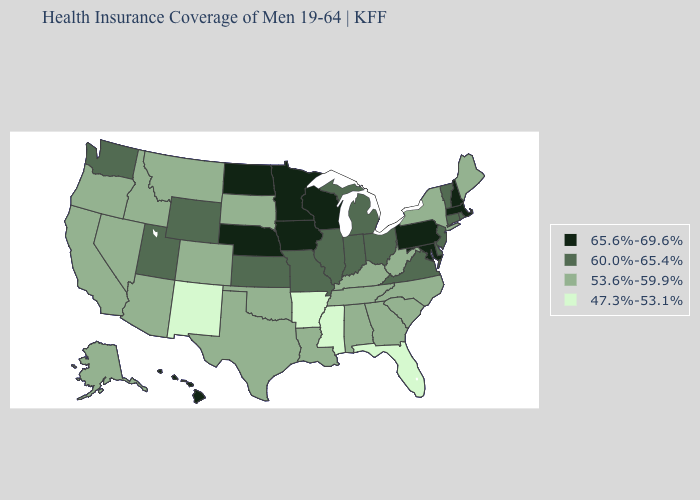Name the states that have a value in the range 60.0%-65.4%?
Be succinct. Connecticut, Delaware, Illinois, Indiana, Kansas, Michigan, Missouri, New Jersey, Ohio, Rhode Island, Utah, Vermont, Virginia, Washington, Wyoming. Does Nebraska have the highest value in the USA?
Keep it brief. Yes. Name the states that have a value in the range 65.6%-69.6%?
Give a very brief answer. Hawaii, Iowa, Maryland, Massachusetts, Minnesota, Nebraska, New Hampshire, North Dakota, Pennsylvania, Wisconsin. Name the states that have a value in the range 47.3%-53.1%?
Be succinct. Arkansas, Florida, Mississippi, New Mexico. Is the legend a continuous bar?
Answer briefly. No. What is the value of Massachusetts?
Be succinct. 65.6%-69.6%. Which states hav the highest value in the MidWest?
Short answer required. Iowa, Minnesota, Nebraska, North Dakota, Wisconsin. Name the states that have a value in the range 53.6%-59.9%?
Quick response, please. Alabama, Alaska, Arizona, California, Colorado, Georgia, Idaho, Kentucky, Louisiana, Maine, Montana, Nevada, New York, North Carolina, Oklahoma, Oregon, South Carolina, South Dakota, Tennessee, Texas, West Virginia. How many symbols are there in the legend?
Be succinct. 4. Name the states that have a value in the range 47.3%-53.1%?
Answer briefly. Arkansas, Florida, Mississippi, New Mexico. Among the states that border Wyoming , does Montana have the lowest value?
Write a very short answer. Yes. Name the states that have a value in the range 47.3%-53.1%?
Write a very short answer. Arkansas, Florida, Mississippi, New Mexico. Does the map have missing data?
Concise answer only. No. What is the lowest value in the USA?
Concise answer only. 47.3%-53.1%. Name the states that have a value in the range 60.0%-65.4%?
Concise answer only. Connecticut, Delaware, Illinois, Indiana, Kansas, Michigan, Missouri, New Jersey, Ohio, Rhode Island, Utah, Vermont, Virginia, Washington, Wyoming. 